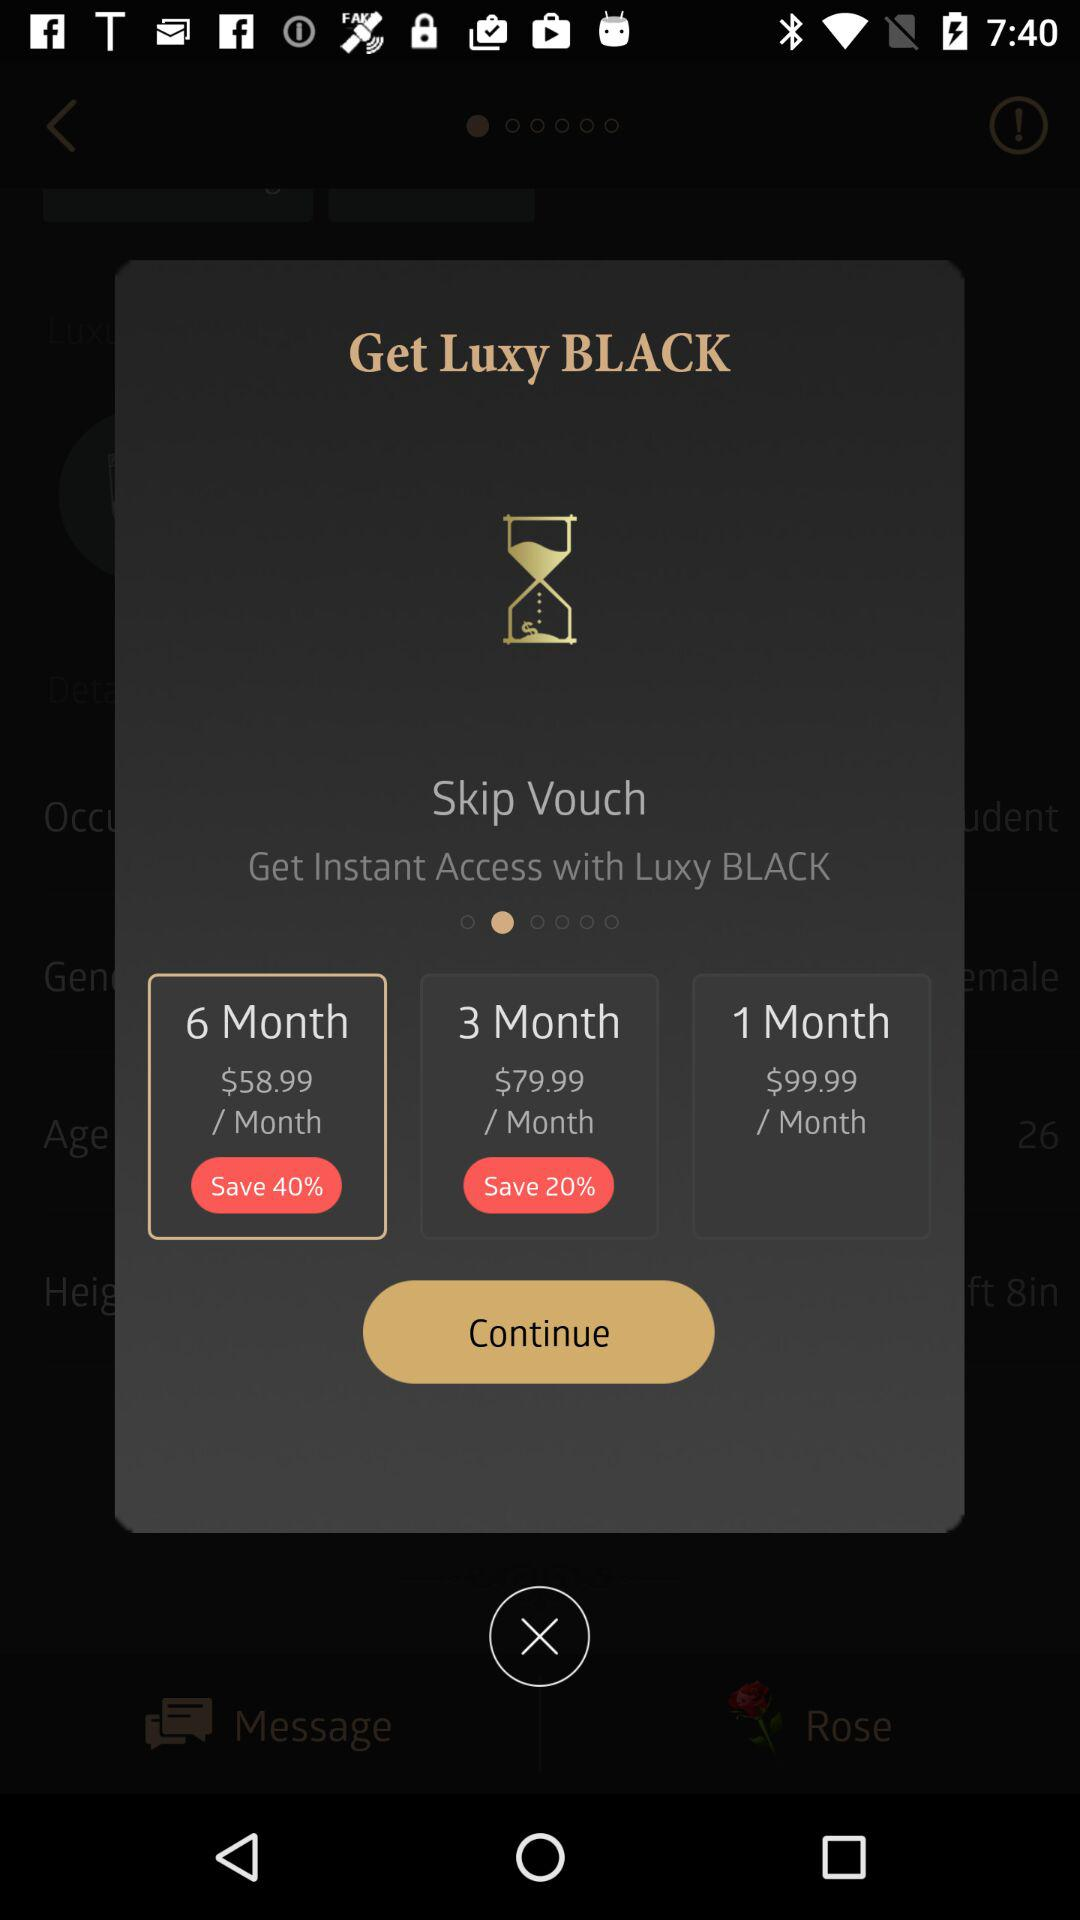How much is the discount for the 6-month subscription? The discount is 40%. 